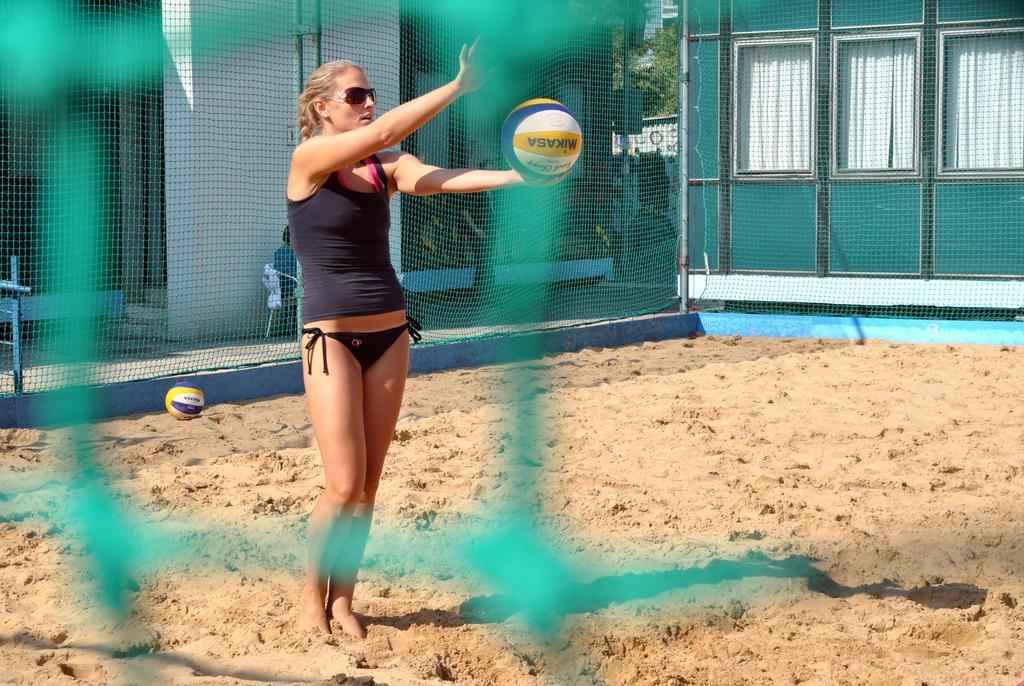In one or two sentences, can you explain what this image depicts? In this image through the net we can see there is a woman standing on the sand is holding a volleyball in her hand, behind the woman there is a ball in the sand, behind the ball there is a net with metal rods, behind the net there is a person sitting in the chair, beside the person there is another person standing. Behind them there are buildings with glass windows and there are traffic lights with sign boards behind that there are trees. On the left side of the image there is a metal rod fence. 